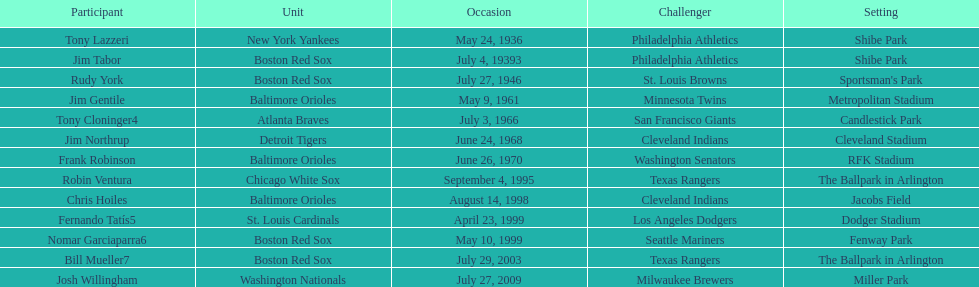What is the name of the player for the new york yankees in 1936? Tony Lazzeri. Help me parse the entirety of this table. {'header': ['Participant', 'Unit', 'Occasion', 'Challenger', 'Setting'], 'rows': [['Tony Lazzeri', 'New York Yankees', 'May 24, 1936', 'Philadelphia Athletics', 'Shibe Park'], ['Jim Tabor', 'Boston Red Sox', 'July 4, 19393', 'Philadelphia Athletics', 'Shibe Park'], ['Rudy York', 'Boston Red Sox', 'July 27, 1946', 'St. Louis Browns', "Sportsman's Park"], ['Jim Gentile', 'Baltimore Orioles', 'May 9, 1961', 'Minnesota Twins', 'Metropolitan Stadium'], ['Tony Cloninger4', 'Atlanta Braves', 'July 3, 1966', 'San Francisco Giants', 'Candlestick Park'], ['Jim Northrup', 'Detroit Tigers', 'June 24, 1968', 'Cleveland Indians', 'Cleveland Stadium'], ['Frank Robinson', 'Baltimore Orioles', 'June 26, 1970', 'Washington Senators', 'RFK Stadium'], ['Robin Ventura', 'Chicago White Sox', 'September 4, 1995', 'Texas Rangers', 'The Ballpark in Arlington'], ['Chris Hoiles', 'Baltimore Orioles', 'August 14, 1998', 'Cleveland Indians', 'Jacobs Field'], ['Fernando Tatís5', 'St. Louis Cardinals', 'April 23, 1999', 'Los Angeles Dodgers', 'Dodger Stadium'], ['Nomar Garciaparra6', 'Boston Red Sox', 'May 10, 1999', 'Seattle Mariners', 'Fenway Park'], ['Bill Mueller7', 'Boston Red Sox', 'July 29, 2003', 'Texas Rangers', 'The Ballpark in Arlington'], ['Josh Willingham', 'Washington Nationals', 'July 27, 2009', 'Milwaukee Brewers', 'Miller Park']]} 